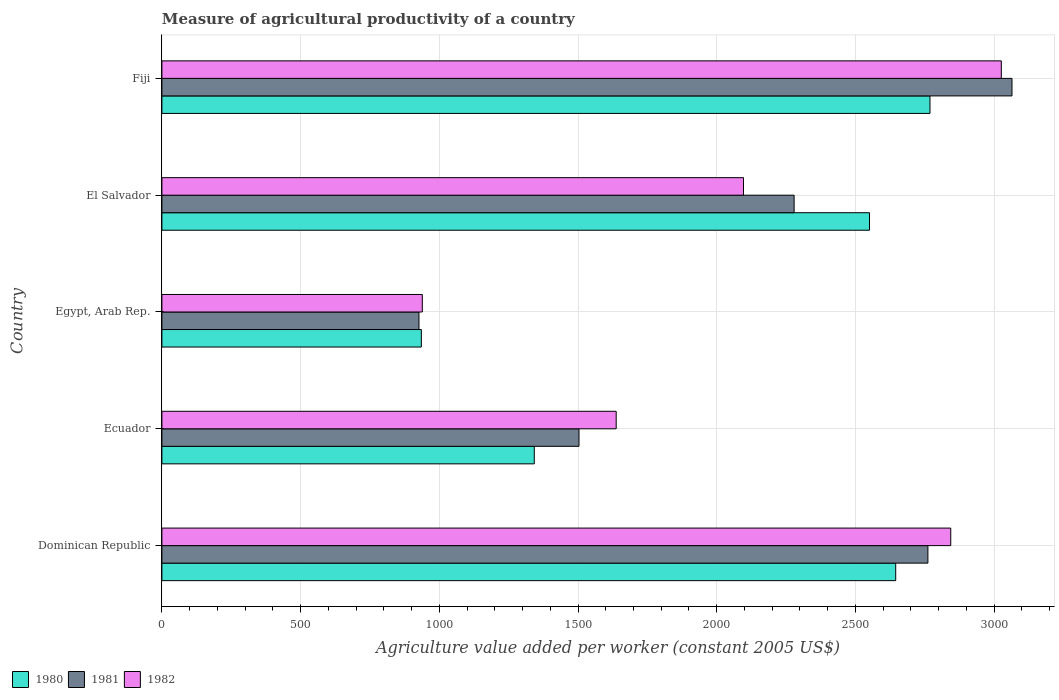How many different coloured bars are there?
Ensure brevity in your answer.  3. Are the number of bars per tick equal to the number of legend labels?
Give a very brief answer. Yes. How many bars are there on the 1st tick from the top?
Your answer should be very brief. 3. What is the label of the 2nd group of bars from the top?
Make the answer very short. El Salvador. In how many cases, is the number of bars for a given country not equal to the number of legend labels?
Keep it short and to the point. 0. What is the measure of agricultural productivity in 1982 in Dominican Republic?
Provide a succinct answer. 2843.79. Across all countries, what is the maximum measure of agricultural productivity in 1980?
Your answer should be compact. 2768.91. Across all countries, what is the minimum measure of agricultural productivity in 1982?
Give a very brief answer. 938.78. In which country was the measure of agricultural productivity in 1980 maximum?
Your answer should be compact. Fiji. In which country was the measure of agricultural productivity in 1981 minimum?
Provide a succinct answer. Egypt, Arab Rep. What is the total measure of agricultural productivity in 1981 in the graph?
Your answer should be compact. 1.05e+04. What is the difference between the measure of agricultural productivity in 1980 in Dominican Republic and that in Fiji?
Offer a terse response. -123.6. What is the difference between the measure of agricultural productivity in 1982 in El Salvador and the measure of agricultural productivity in 1980 in Dominican Republic?
Offer a terse response. -548.66. What is the average measure of agricultural productivity in 1981 per country?
Offer a terse response. 2107.08. What is the difference between the measure of agricultural productivity in 1982 and measure of agricultural productivity in 1981 in Dominican Republic?
Ensure brevity in your answer.  82.38. In how many countries, is the measure of agricultural productivity in 1982 greater than 2200 US$?
Offer a terse response. 2. What is the ratio of the measure of agricultural productivity in 1980 in Dominican Republic to that in El Salvador?
Your answer should be compact. 1.04. Is the measure of agricultural productivity in 1981 in El Salvador less than that in Fiji?
Your answer should be compact. Yes. Is the difference between the measure of agricultural productivity in 1982 in Ecuador and El Salvador greater than the difference between the measure of agricultural productivity in 1981 in Ecuador and El Salvador?
Provide a succinct answer. Yes. What is the difference between the highest and the second highest measure of agricultural productivity in 1982?
Ensure brevity in your answer.  182.3. What is the difference between the highest and the lowest measure of agricultural productivity in 1982?
Your answer should be very brief. 2087.31. In how many countries, is the measure of agricultural productivity in 1980 greater than the average measure of agricultural productivity in 1980 taken over all countries?
Ensure brevity in your answer.  3. Is the sum of the measure of agricultural productivity in 1980 in Dominican Republic and Ecuador greater than the maximum measure of agricultural productivity in 1981 across all countries?
Give a very brief answer. Yes. What does the 1st bar from the bottom in Ecuador represents?
Provide a succinct answer. 1980. Is it the case that in every country, the sum of the measure of agricultural productivity in 1981 and measure of agricultural productivity in 1982 is greater than the measure of agricultural productivity in 1980?
Provide a succinct answer. Yes. Are the values on the major ticks of X-axis written in scientific E-notation?
Your answer should be very brief. No. Does the graph contain any zero values?
Offer a terse response. No. How many legend labels are there?
Your response must be concise. 3. How are the legend labels stacked?
Make the answer very short. Horizontal. What is the title of the graph?
Provide a short and direct response. Measure of agricultural productivity of a country. What is the label or title of the X-axis?
Provide a succinct answer. Agriculture value added per worker (constant 2005 US$). What is the label or title of the Y-axis?
Offer a very short reply. Country. What is the Agriculture value added per worker (constant 2005 US$) of 1980 in Dominican Republic?
Your answer should be very brief. 2645.31. What is the Agriculture value added per worker (constant 2005 US$) of 1981 in Dominican Republic?
Provide a short and direct response. 2761.41. What is the Agriculture value added per worker (constant 2005 US$) in 1982 in Dominican Republic?
Give a very brief answer. 2843.79. What is the Agriculture value added per worker (constant 2005 US$) of 1980 in Ecuador?
Provide a succinct answer. 1342.41. What is the Agriculture value added per worker (constant 2005 US$) of 1981 in Ecuador?
Your answer should be very brief. 1503.63. What is the Agriculture value added per worker (constant 2005 US$) of 1982 in Ecuador?
Keep it short and to the point. 1637.69. What is the Agriculture value added per worker (constant 2005 US$) in 1980 in Egypt, Arab Rep.?
Your response must be concise. 935.25. What is the Agriculture value added per worker (constant 2005 US$) of 1981 in Egypt, Arab Rep.?
Provide a short and direct response. 926.69. What is the Agriculture value added per worker (constant 2005 US$) of 1982 in Egypt, Arab Rep.?
Give a very brief answer. 938.78. What is the Agriculture value added per worker (constant 2005 US$) of 1980 in El Salvador?
Provide a short and direct response. 2550.82. What is the Agriculture value added per worker (constant 2005 US$) of 1981 in El Salvador?
Provide a short and direct response. 2279.12. What is the Agriculture value added per worker (constant 2005 US$) of 1982 in El Salvador?
Give a very brief answer. 2096.65. What is the Agriculture value added per worker (constant 2005 US$) of 1980 in Fiji?
Keep it short and to the point. 2768.91. What is the Agriculture value added per worker (constant 2005 US$) of 1981 in Fiji?
Keep it short and to the point. 3064.53. What is the Agriculture value added per worker (constant 2005 US$) in 1982 in Fiji?
Your answer should be compact. 3026.09. Across all countries, what is the maximum Agriculture value added per worker (constant 2005 US$) of 1980?
Provide a short and direct response. 2768.91. Across all countries, what is the maximum Agriculture value added per worker (constant 2005 US$) in 1981?
Offer a terse response. 3064.53. Across all countries, what is the maximum Agriculture value added per worker (constant 2005 US$) in 1982?
Ensure brevity in your answer.  3026.09. Across all countries, what is the minimum Agriculture value added per worker (constant 2005 US$) of 1980?
Ensure brevity in your answer.  935.25. Across all countries, what is the minimum Agriculture value added per worker (constant 2005 US$) of 1981?
Ensure brevity in your answer.  926.69. Across all countries, what is the minimum Agriculture value added per worker (constant 2005 US$) in 1982?
Your response must be concise. 938.78. What is the total Agriculture value added per worker (constant 2005 US$) of 1980 in the graph?
Your response must be concise. 1.02e+04. What is the total Agriculture value added per worker (constant 2005 US$) in 1981 in the graph?
Provide a succinct answer. 1.05e+04. What is the total Agriculture value added per worker (constant 2005 US$) of 1982 in the graph?
Offer a terse response. 1.05e+04. What is the difference between the Agriculture value added per worker (constant 2005 US$) in 1980 in Dominican Republic and that in Ecuador?
Offer a very short reply. 1302.9. What is the difference between the Agriculture value added per worker (constant 2005 US$) in 1981 in Dominican Republic and that in Ecuador?
Provide a short and direct response. 1257.78. What is the difference between the Agriculture value added per worker (constant 2005 US$) of 1982 in Dominican Republic and that in Ecuador?
Give a very brief answer. 1206.1. What is the difference between the Agriculture value added per worker (constant 2005 US$) of 1980 in Dominican Republic and that in Egypt, Arab Rep.?
Offer a very short reply. 1710.06. What is the difference between the Agriculture value added per worker (constant 2005 US$) of 1981 in Dominican Republic and that in Egypt, Arab Rep.?
Provide a short and direct response. 1834.72. What is the difference between the Agriculture value added per worker (constant 2005 US$) in 1982 in Dominican Republic and that in Egypt, Arab Rep.?
Your answer should be compact. 1905.01. What is the difference between the Agriculture value added per worker (constant 2005 US$) in 1980 in Dominican Republic and that in El Salvador?
Give a very brief answer. 94.49. What is the difference between the Agriculture value added per worker (constant 2005 US$) of 1981 in Dominican Republic and that in El Salvador?
Offer a very short reply. 482.29. What is the difference between the Agriculture value added per worker (constant 2005 US$) in 1982 in Dominican Republic and that in El Salvador?
Ensure brevity in your answer.  747.14. What is the difference between the Agriculture value added per worker (constant 2005 US$) in 1980 in Dominican Republic and that in Fiji?
Keep it short and to the point. -123.6. What is the difference between the Agriculture value added per worker (constant 2005 US$) of 1981 in Dominican Republic and that in Fiji?
Your response must be concise. -303.11. What is the difference between the Agriculture value added per worker (constant 2005 US$) in 1982 in Dominican Republic and that in Fiji?
Provide a succinct answer. -182.3. What is the difference between the Agriculture value added per worker (constant 2005 US$) in 1980 in Ecuador and that in Egypt, Arab Rep.?
Offer a very short reply. 407.15. What is the difference between the Agriculture value added per worker (constant 2005 US$) in 1981 in Ecuador and that in Egypt, Arab Rep.?
Make the answer very short. 576.94. What is the difference between the Agriculture value added per worker (constant 2005 US$) of 1982 in Ecuador and that in Egypt, Arab Rep.?
Your answer should be very brief. 698.91. What is the difference between the Agriculture value added per worker (constant 2005 US$) in 1980 in Ecuador and that in El Salvador?
Offer a very short reply. -1208.42. What is the difference between the Agriculture value added per worker (constant 2005 US$) of 1981 in Ecuador and that in El Salvador?
Provide a short and direct response. -775.49. What is the difference between the Agriculture value added per worker (constant 2005 US$) of 1982 in Ecuador and that in El Salvador?
Your response must be concise. -458.96. What is the difference between the Agriculture value added per worker (constant 2005 US$) of 1980 in Ecuador and that in Fiji?
Your answer should be very brief. -1426.51. What is the difference between the Agriculture value added per worker (constant 2005 US$) in 1981 in Ecuador and that in Fiji?
Your answer should be very brief. -1560.9. What is the difference between the Agriculture value added per worker (constant 2005 US$) in 1982 in Ecuador and that in Fiji?
Ensure brevity in your answer.  -1388.4. What is the difference between the Agriculture value added per worker (constant 2005 US$) of 1980 in Egypt, Arab Rep. and that in El Salvador?
Ensure brevity in your answer.  -1615.57. What is the difference between the Agriculture value added per worker (constant 2005 US$) of 1981 in Egypt, Arab Rep. and that in El Salvador?
Provide a short and direct response. -1352.43. What is the difference between the Agriculture value added per worker (constant 2005 US$) of 1982 in Egypt, Arab Rep. and that in El Salvador?
Offer a very short reply. -1157.87. What is the difference between the Agriculture value added per worker (constant 2005 US$) in 1980 in Egypt, Arab Rep. and that in Fiji?
Offer a very short reply. -1833.66. What is the difference between the Agriculture value added per worker (constant 2005 US$) in 1981 in Egypt, Arab Rep. and that in Fiji?
Offer a terse response. -2137.83. What is the difference between the Agriculture value added per worker (constant 2005 US$) of 1982 in Egypt, Arab Rep. and that in Fiji?
Keep it short and to the point. -2087.31. What is the difference between the Agriculture value added per worker (constant 2005 US$) of 1980 in El Salvador and that in Fiji?
Your response must be concise. -218.09. What is the difference between the Agriculture value added per worker (constant 2005 US$) of 1981 in El Salvador and that in Fiji?
Your response must be concise. -785.41. What is the difference between the Agriculture value added per worker (constant 2005 US$) in 1982 in El Salvador and that in Fiji?
Provide a short and direct response. -929.44. What is the difference between the Agriculture value added per worker (constant 2005 US$) in 1980 in Dominican Republic and the Agriculture value added per worker (constant 2005 US$) in 1981 in Ecuador?
Give a very brief answer. 1141.68. What is the difference between the Agriculture value added per worker (constant 2005 US$) of 1980 in Dominican Republic and the Agriculture value added per worker (constant 2005 US$) of 1982 in Ecuador?
Provide a short and direct response. 1007.62. What is the difference between the Agriculture value added per worker (constant 2005 US$) of 1981 in Dominican Republic and the Agriculture value added per worker (constant 2005 US$) of 1982 in Ecuador?
Ensure brevity in your answer.  1123.72. What is the difference between the Agriculture value added per worker (constant 2005 US$) of 1980 in Dominican Republic and the Agriculture value added per worker (constant 2005 US$) of 1981 in Egypt, Arab Rep.?
Your response must be concise. 1718.62. What is the difference between the Agriculture value added per worker (constant 2005 US$) in 1980 in Dominican Republic and the Agriculture value added per worker (constant 2005 US$) in 1982 in Egypt, Arab Rep.?
Offer a terse response. 1706.53. What is the difference between the Agriculture value added per worker (constant 2005 US$) in 1981 in Dominican Republic and the Agriculture value added per worker (constant 2005 US$) in 1982 in Egypt, Arab Rep.?
Your answer should be very brief. 1822.63. What is the difference between the Agriculture value added per worker (constant 2005 US$) of 1980 in Dominican Republic and the Agriculture value added per worker (constant 2005 US$) of 1981 in El Salvador?
Offer a very short reply. 366.19. What is the difference between the Agriculture value added per worker (constant 2005 US$) in 1980 in Dominican Republic and the Agriculture value added per worker (constant 2005 US$) in 1982 in El Salvador?
Keep it short and to the point. 548.66. What is the difference between the Agriculture value added per worker (constant 2005 US$) of 1981 in Dominican Republic and the Agriculture value added per worker (constant 2005 US$) of 1982 in El Salvador?
Make the answer very short. 664.76. What is the difference between the Agriculture value added per worker (constant 2005 US$) of 1980 in Dominican Republic and the Agriculture value added per worker (constant 2005 US$) of 1981 in Fiji?
Ensure brevity in your answer.  -419.21. What is the difference between the Agriculture value added per worker (constant 2005 US$) of 1980 in Dominican Republic and the Agriculture value added per worker (constant 2005 US$) of 1982 in Fiji?
Your answer should be compact. -380.78. What is the difference between the Agriculture value added per worker (constant 2005 US$) of 1981 in Dominican Republic and the Agriculture value added per worker (constant 2005 US$) of 1982 in Fiji?
Offer a terse response. -264.68. What is the difference between the Agriculture value added per worker (constant 2005 US$) in 1980 in Ecuador and the Agriculture value added per worker (constant 2005 US$) in 1981 in Egypt, Arab Rep.?
Provide a succinct answer. 415.71. What is the difference between the Agriculture value added per worker (constant 2005 US$) of 1980 in Ecuador and the Agriculture value added per worker (constant 2005 US$) of 1982 in Egypt, Arab Rep.?
Keep it short and to the point. 403.63. What is the difference between the Agriculture value added per worker (constant 2005 US$) in 1981 in Ecuador and the Agriculture value added per worker (constant 2005 US$) in 1982 in Egypt, Arab Rep.?
Offer a very short reply. 564.85. What is the difference between the Agriculture value added per worker (constant 2005 US$) in 1980 in Ecuador and the Agriculture value added per worker (constant 2005 US$) in 1981 in El Salvador?
Offer a very short reply. -936.71. What is the difference between the Agriculture value added per worker (constant 2005 US$) in 1980 in Ecuador and the Agriculture value added per worker (constant 2005 US$) in 1982 in El Salvador?
Keep it short and to the point. -754.24. What is the difference between the Agriculture value added per worker (constant 2005 US$) in 1981 in Ecuador and the Agriculture value added per worker (constant 2005 US$) in 1982 in El Salvador?
Provide a short and direct response. -593.02. What is the difference between the Agriculture value added per worker (constant 2005 US$) in 1980 in Ecuador and the Agriculture value added per worker (constant 2005 US$) in 1981 in Fiji?
Give a very brief answer. -1722.12. What is the difference between the Agriculture value added per worker (constant 2005 US$) in 1980 in Ecuador and the Agriculture value added per worker (constant 2005 US$) in 1982 in Fiji?
Give a very brief answer. -1683.68. What is the difference between the Agriculture value added per worker (constant 2005 US$) of 1981 in Ecuador and the Agriculture value added per worker (constant 2005 US$) of 1982 in Fiji?
Keep it short and to the point. -1522.46. What is the difference between the Agriculture value added per worker (constant 2005 US$) in 1980 in Egypt, Arab Rep. and the Agriculture value added per worker (constant 2005 US$) in 1981 in El Salvador?
Offer a terse response. -1343.87. What is the difference between the Agriculture value added per worker (constant 2005 US$) of 1980 in Egypt, Arab Rep. and the Agriculture value added per worker (constant 2005 US$) of 1982 in El Salvador?
Offer a terse response. -1161.4. What is the difference between the Agriculture value added per worker (constant 2005 US$) of 1981 in Egypt, Arab Rep. and the Agriculture value added per worker (constant 2005 US$) of 1982 in El Salvador?
Your answer should be compact. -1169.96. What is the difference between the Agriculture value added per worker (constant 2005 US$) in 1980 in Egypt, Arab Rep. and the Agriculture value added per worker (constant 2005 US$) in 1981 in Fiji?
Give a very brief answer. -2129.27. What is the difference between the Agriculture value added per worker (constant 2005 US$) in 1980 in Egypt, Arab Rep. and the Agriculture value added per worker (constant 2005 US$) in 1982 in Fiji?
Provide a succinct answer. -2090.84. What is the difference between the Agriculture value added per worker (constant 2005 US$) in 1981 in Egypt, Arab Rep. and the Agriculture value added per worker (constant 2005 US$) in 1982 in Fiji?
Your answer should be very brief. -2099.4. What is the difference between the Agriculture value added per worker (constant 2005 US$) in 1980 in El Salvador and the Agriculture value added per worker (constant 2005 US$) in 1981 in Fiji?
Offer a very short reply. -513.7. What is the difference between the Agriculture value added per worker (constant 2005 US$) in 1980 in El Salvador and the Agriculture value added per worker (constant 2005 US$) in 1982 in Fiji?
Offer a very short reply. -475.27. What is the difference between the Agriculture value added per worker (constant 2005 US$) of 1981 in El Salvador and the Agriculture value added per worker (constant 2005 US$) of 1982 in Fiji?
Provide a succinct answer. -746.97. What is the average Agriculture value added per worker (constant 2005 US$) of 1980 per country?
Give a very brief answer. 2048.54. What is the average Agriculture value added per worker (constant 2005 US$) of 1981 per country?
Provide a succinct answer. 2107.08. What is the average Agriculture value added per worker (constant 2005 US$) of 1982 per country?
Provide a short and direct response. 2108.6. What is the difference between the Agriculture value added per worker (constant 2005 US$) of 1980 and Agriculture value added per worker (constant 2005 US$) of 1981 in Dominican Republic?
Your response must be concise. -116.1. What is the difference between the Agriculture value added per worker (constant 2005 US$) of 1980 and Agriculture value added per worker (constant 2005 US$) of 1982 in Dominican Republic?
Provide a short and direct response. -198.48. What is the difference between the Agriculture value added per worker (constant 2005 US$) of 1981 and Agriculture value added per worker (constant 2005 US$) of 1982 in Dominican Republic?
Make the answer very short. -82.38. What is the difference between the Agriculture value added per worker (constant 2005 US$) of 1980 and Agriculture value added per worker (constant 2005 US$) of 1981 in Ecuador?
Give a very brief answer. -161.22. What is the difference between the Agriculture value added per worker (constant 2005 US$) in 1980 and Agriculture value added per worker (constant 2005 US$) in 1982 in Ecuador?
Your response must be concise. -295.29. What is the difference between the Agriculture value added per worker (constant 2005 US$) of 1981 and Agriculture value added per worker (constant 2005 US$) of 1982 in Ecuador?
Keep it short and to the point. -134.06. What is the difference between the Agriculture value added per worker (constant 2005 US$) of 1980 and Agriculture value added per worker (constant 2005 US$) of 1981 in Egypt, Arab Rep.?
Make the answer very short. 8.56. What is the difference between the Agriculture value added per worker (constant 2005 US$) in 1980 and Agriculture value added per worker (constant 2005 US$) in 1982 in Egypt, Arab Rep.?
Your answer should be compact. -3.53. What is the difference between the Agriculture value added per worker (constant 2005 US$) in 1981 and Agriculture value added per worker (constant 2005 US$) in 1982 in Egypt, Arab Rep.?
Make the answer very short. -12.09. What is the difference between the Agriculture value added per worker (constant 2005 US$) in 1980 and Agriculture value added per worker (constant 2005 US$) in 1981 in El Salvador?
Keep it short and to the point. 271.71. What is the difference between the Agriculture value added per worker (constant 2005 US$) of 1980 and Agriculture value added per worker (constant 2005 US$) of 1982 in El Salvador?
Make the answer very short. 454.18. What is the difference between the Agriculture value added per worker (constant 2005 US$) in 1981 and Agriculture value added per worker (constant 2005 US$) in 1982 in El Salvador?
Offer a very short reply. 182.47. What is the difference between the Agriculture value added per worker (constant 2005 US$) in 1980 and Agriculture value added per worker (constant 2005 US$) in 1981 in Fiji?
Ensure brevity in your answer.  -295.61. What is the difference between the Agriculture value added per worker (constant 2005 US$) in 1980 and Agriculture value added per worker (constant 2005 US$) in 1982 in Fiji?
Keep it short and to the point. -257.18. What is the difference between the Agriculture value added per worker (constant 2005 US$) in 1981 and Agriculture value added per worker (constant 2005 US$) in 1982 in Fiji?
Ensure brevity in your answer.  38.43. What is the ratio of the Agriculture value added per worker (constant 2005 US$) in 1980 in Dominican Republic to that in Ecuador?
Your answer should be very brief. 1.97. What is the ratio of the Agriculture value added per worker (constant 2005 US$) in 1981 in Dominican Republic to that in Ecuador?
Offer a very short reply. 1.84. What is the ratio of the Agriculture value added per worker (constant 2005 US$) of 1982 in Dominican Republic to that in Ecuador?
Your answer should be compact. 1.74. What is the ratio of the Agriculture value added per worker (constant 2005 US$) of 1980 in Dominican Republic to that in Egypt, Arab Rep.?
Provide a succinct answer. 2.83. What is the ratio of the Agriculture value added per worker (constant 2005 US$) in 1981 in Dominican Republic to that in Egypt, Arab Rep.?
Offer a very short reply. 2.98. What is the ratio of the Agriculture value added per worker (constant 2005 US$) in 1982 in Dominican Republic to that in Egypt, Arab Rep.?
Ensure brevity in your answer.  3.03. What is the ratio of the Agriculture value added per worker (constant 2005 US$) of 1981 in Dominican Republic to that in El Salvador?
Keep it short and to the point. 1.21. What is the ratio of the Agriculture value added per worker (constant 2005 US$) of 1982 in Dominican Republic to that in El Salvador?
Your response must be concise. 1.36. What is the ratio of the Agriculture value added per worker (constant 2005 US$) in 1980 in Dominican Republic to that in Fiji?
Your answer should be compact. 0.96. What is the ratio of the Agriculture value added per worker (constant 2005 US$) of 1981 in Dominican Republic to that in Fiji?
Your answer should be very brief. 0.9. What is the ratio of the Agriculture value added per worker (constant 2005 US$) of 1982 in Dominican Republic to that in Fiji?
Provide a succinct answer. 0.94. What is the ratio of the Agriculture value added per worker (constant 2005 US$) of 1980 in Ecuador to that in Egypt, Arab Rep.?
Give a very brief answer. 1.44. What is the ratio of the Agriculture value added per worker (constant 2005 US$) of 1981 in Ecuador to that in Egypt, Arab Rep.?
Make the answer very short. 1.62. What is the ratio of the Agriculture value added per worker (constant 2005 US$) in 1982 in Ecuador to that in Egypt, Arab Rep.?
Make the answer very short. 1.74. What is the ratio of the Agriculture value added per worker (constant 2005 US$) in 1980 in Ecuador to that in El Salvador?
Keep it short and to the point. 0.53. What is the ratio of the Agriculture value added per worker (constant 2005 US$) of 1981 in Ecuador to that in El Salvador?
Offer a very short reply. 0.66. What is the ratio of the Agriculture value added per worker (constant 2005 US$) in 1982 in Ecuador to that in El Salvador?
Your response must be concise. 0.78. What is the ratio of the Agriculture value added per worker (constant 2005 US$) in 1980 in Ecuador to that in Fiji?
Offer a terse response. 0.48. What is the ratio of the Agriculture value added per worker (constant 2005 US$) in 1981 in Ecuador to that in Fiji?
Your response must be concise. 0.49. What is the ratio of the Agriculture value added per worker (constant 2005 US$) of 1982 in Ecuador to that in Fiji?
Ensure brevity in your answer.  0.54. What is the ratio of the Agriculture value added per worker (constant 2005 US$) in 1980 in Egypt, Arab Rep. to that in El Salvador?
Provide a succinct answer. 0.37. What is the ratio of the Agriculture value added per worker (constant 2005 US$) of 1981 in Egypt, Arab Rep. to that in El Salvador?
Provide a succinct answer. 0.41. What is the ratio of the Agriculture value added per worker (constant 2005 US$) of 1982 in Egypt, Arab Rep. to that in El Salvador?
Ensure brevity in your answer.  0.45. What is the ratio of the Agriculture value added per worker (constant 2005 US$) of 1980 in Egypt, Arab Rep. to that in Fiji?
Ensure brevity in your answer.  0.34. What is the ratio of the Agriculture value added per worker (constant 2005 US$) of 1981 in Egypt, Arab Rep. to that in Fiji?
Give a very brief answer. 0.3. What is the ratio of the Agriculture value added per worker (constant 2005 US$) in 1982 in Egypt, Arab Rep. to that in Fiji?
Offer a terse response. 0.31. What is the ratio of the Agriculture value added per worker (constant 2005 US$) of 1980 in El Salvador to that in Fiji?
Keep it short and to the point. 0.92. What is the ratio of the Agriculture value added per worker (constant 2005 US$) of 1981 in El Salvador to that in Fiji?
Offer a terse response. 0.74. What is the ratio of the Agriculture value added per worker (constant 2005 US$) of 1982 in El Salvador to that in Fiji?
Keep it short and to the point. 0.69. What is the difference between the highest and the second highest Agriculture value added per worker (constant 2005 US$) of 1980?
Give a very brief answer. 123.6. What is the difference between the highest and the second highest Agriculture value added per worker (constant 2005 US$) of 1981?
Provide a short and direct response. 303.11. What is the difference between the highest and the second highest Agriculture value added per worker (constant 2005 US$) of 1982?
Your response must be concise. 182.3. What is the difference between the highest and the lowest Agriculture value added per worker (constant 2005 US$) of 1980?
Keep it short and to the point. 1833.66. What is the difference between the highest and the lowest Agriculture value added per worker (constant 2005 US$) in 1981?
Provide a succinct answer. 2137.83. What is the difference between the highest and the lowest Agriculture value added per worker (constant 2005 US$) in 1982?
Ensure brevity in your answer.  2087.31. 